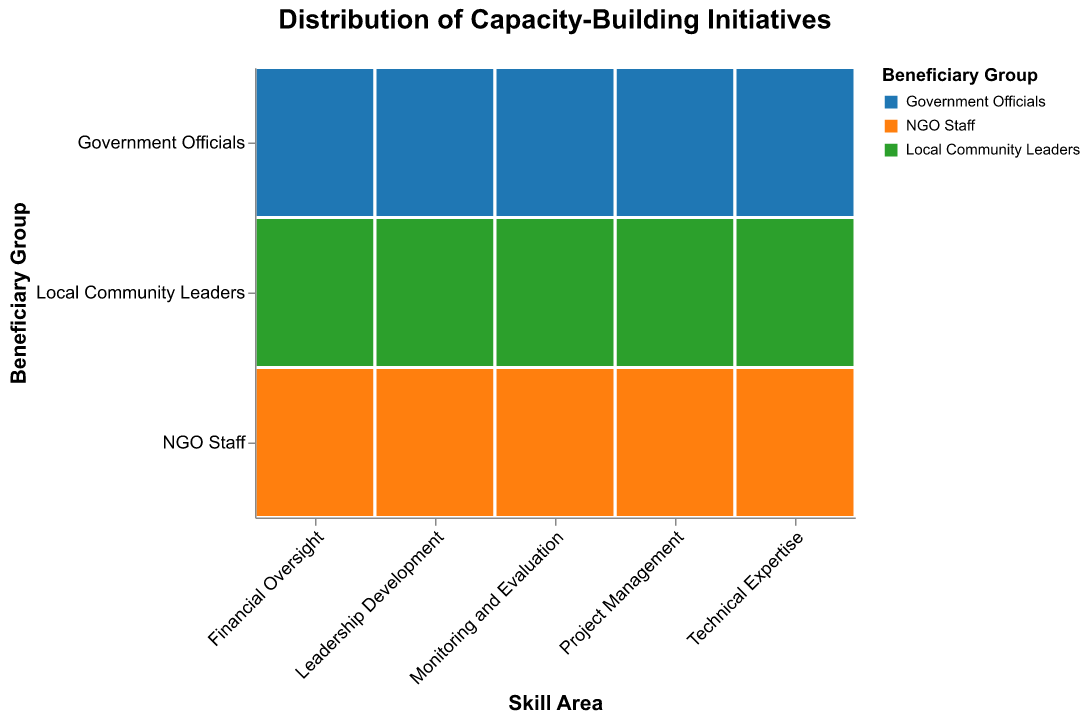What is the skill area with the highest number of initiatives for Government Officials? Find the rectangle corresponding to "Government Officials" under each "Skill Area" and compare their sizes. "Financial Oversight" has the largest size representing the number of initiatives.
Answer: Financial Oversight Which beneficiary group has the least number of initiatives in the Technical Expertise skill area? Locate the "Technical Expertise" skill area and compare the number of initiatives among the beneficiary groups. "Local Community Leaders" have the smallest size in this skill area.
Answer: Local Community Leaders What is the total number of initiatives for NGO Staff across all skill areas? Add the number of initiatives for NGO Staff across all skill areas: 38 (Project Management) + 29 (Financial Oversight) + 41 (Technical Expertise) + 26 (Leadership Development) + 35 (Monitoring and Evaluation) = 169.
Answer: 169 How does the number of initiatives for Local Community Leaders in Leadership Development compare to those in Financial Oversight? Compare the rectangles for "Local Community Leaders" under "Leadership Development" and "Financial Oversight". "Leadership Development" has 33 initiatives while "Financial Oversight" has 15 initiatives.
Answer: 33 initiatives vs. 15 initiatives Which skill area has the most balanced distribution of initiatives among beneficiary groups? Look for the skill area where the rectangle sizes are most similar across beneficiary groups. "Monitoring and Evaluation" seems most balanced with initiatives close to each other: 28, 35, and 20 respectively.
Answer: Monitoring and Evaluation What's the difference in the number of initiatives between Government Officials and Local Community Leaders in Project Management? Subtract the number of initiatives for Local Community Leaders (22) from Government Officials (45) in Project Management. The difference is 45 - 22 = 23.
Answer: 23 What is the average number of initiatives for Government Officials across all skill areas? Add the number of initiatives for Government Officials across all skill areas and divide by the number of skill areas: (45 + 52 + 37 + 31 + 28) / 5 = 193 / 5 = 38.6.
Answer: 38.6 What skill area has the fewest total initiatives across all beneficiary groups? Sum the initiatives for each skill area and compare: 
Project Management: 45 + 38 + 22 = 105
Financial Oversight: 52 + 29 + 15 = 96
Technical Expertise: 37 + 41 + 19 = 97
Leadership Development: 31 + 26 + 33 = 90
Monitoring and Evaluation: 28 + 35 + 20 = 83
"Monitoring and Evaluation" has the fewest initiatives.
Answer: Monitoring and Evaluation How many more initiatives are there for Government Officials compared to Local Community Leaders in Financial Oversight? Subtract the number of initiatives for Local Community Leaders (15) from Government Officials (52). The difference is 52 - 15 = 37.
Answer: 37 Which beneficiary group and skill area combo has exactly 20 initiatives? Look at each rectangle and identify the one with exactly 20 initiatives. "Local Community Leaders" in "Monitoring and Evaluation" have 20 initiatives.
Answer: Local Community Leaders in Monitoring and Evaluation 